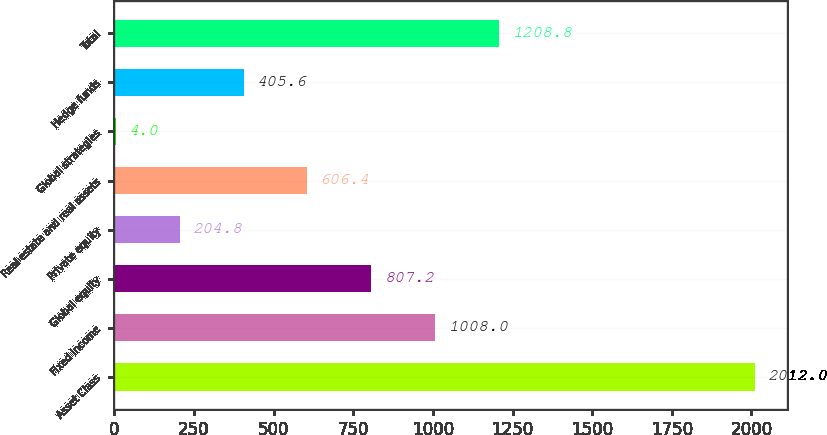Convert chart to OTSL. <chart><loc_0><loc_0><loc_500><loc_500><bar_chart><fcel>Asset Class<fcel>Fixed income<fcel>Global equity<fcel>Private equity<fcel>Real estate and real assets<fcel>Global strategies<fcel>Hedge funds<fcel>Total<nl><fcel>2012<fcel>1008<fcel>807.2<fcel>204.8<fcel>606.4<fcel>4<fcel>405.6<fcel>1208.8<nl></chart> 